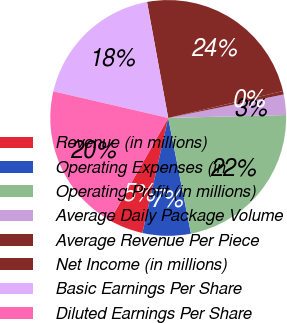<chart> <loc_0><loc_0><loc_500><loc_500><pie_chart><fcel>Revenue (in millions)<fcel>Operating Expenses (in<fcel>Operating Profit (in millions)<fcel>Average Daily Package Volume<fcel>Average Revenue Per Piece<fcel>Net Income (in millions)<fcel>Basic Earnings Per Share<fcel>Diluted Earnings Per Share<nl><fcel>4.71%<fcel>6.61%<fcel>22.3%<fcel>2.8%<fcel>0.47%<fcel>24.21%<fcel>18.5%<fcel>20.4%<nl></chart> 